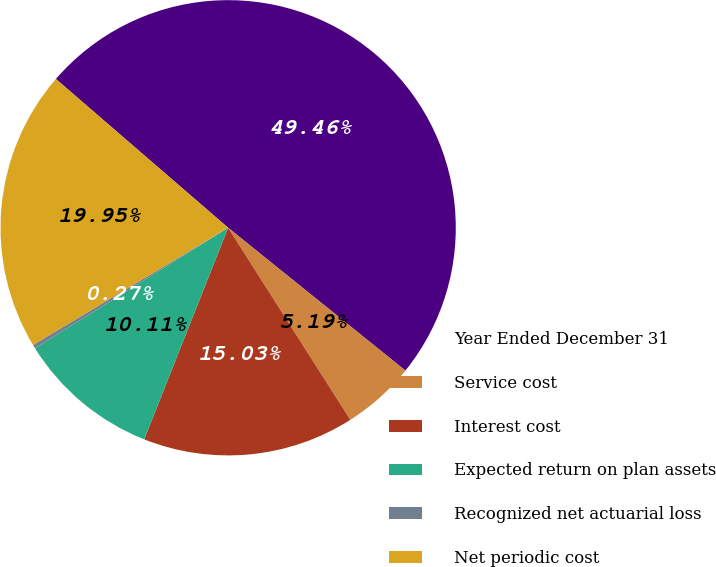Convert chart to OTSL. <chart><loc_0><loc_0><loc_500><loc_500><pie_chart><fcel>Year Ended December 31<fcel>Service cost<fcel>Interest cost<fcel>Expected return on plan assets<fcel>Recognized net actuarial loss<fcel>Net periodic cost<nl><fcel>49.46%<fcel>5.19%<fcel>15.03%<fcel>10.11%<fcel>0.27%<fcel>19.95%<nl></chart> 